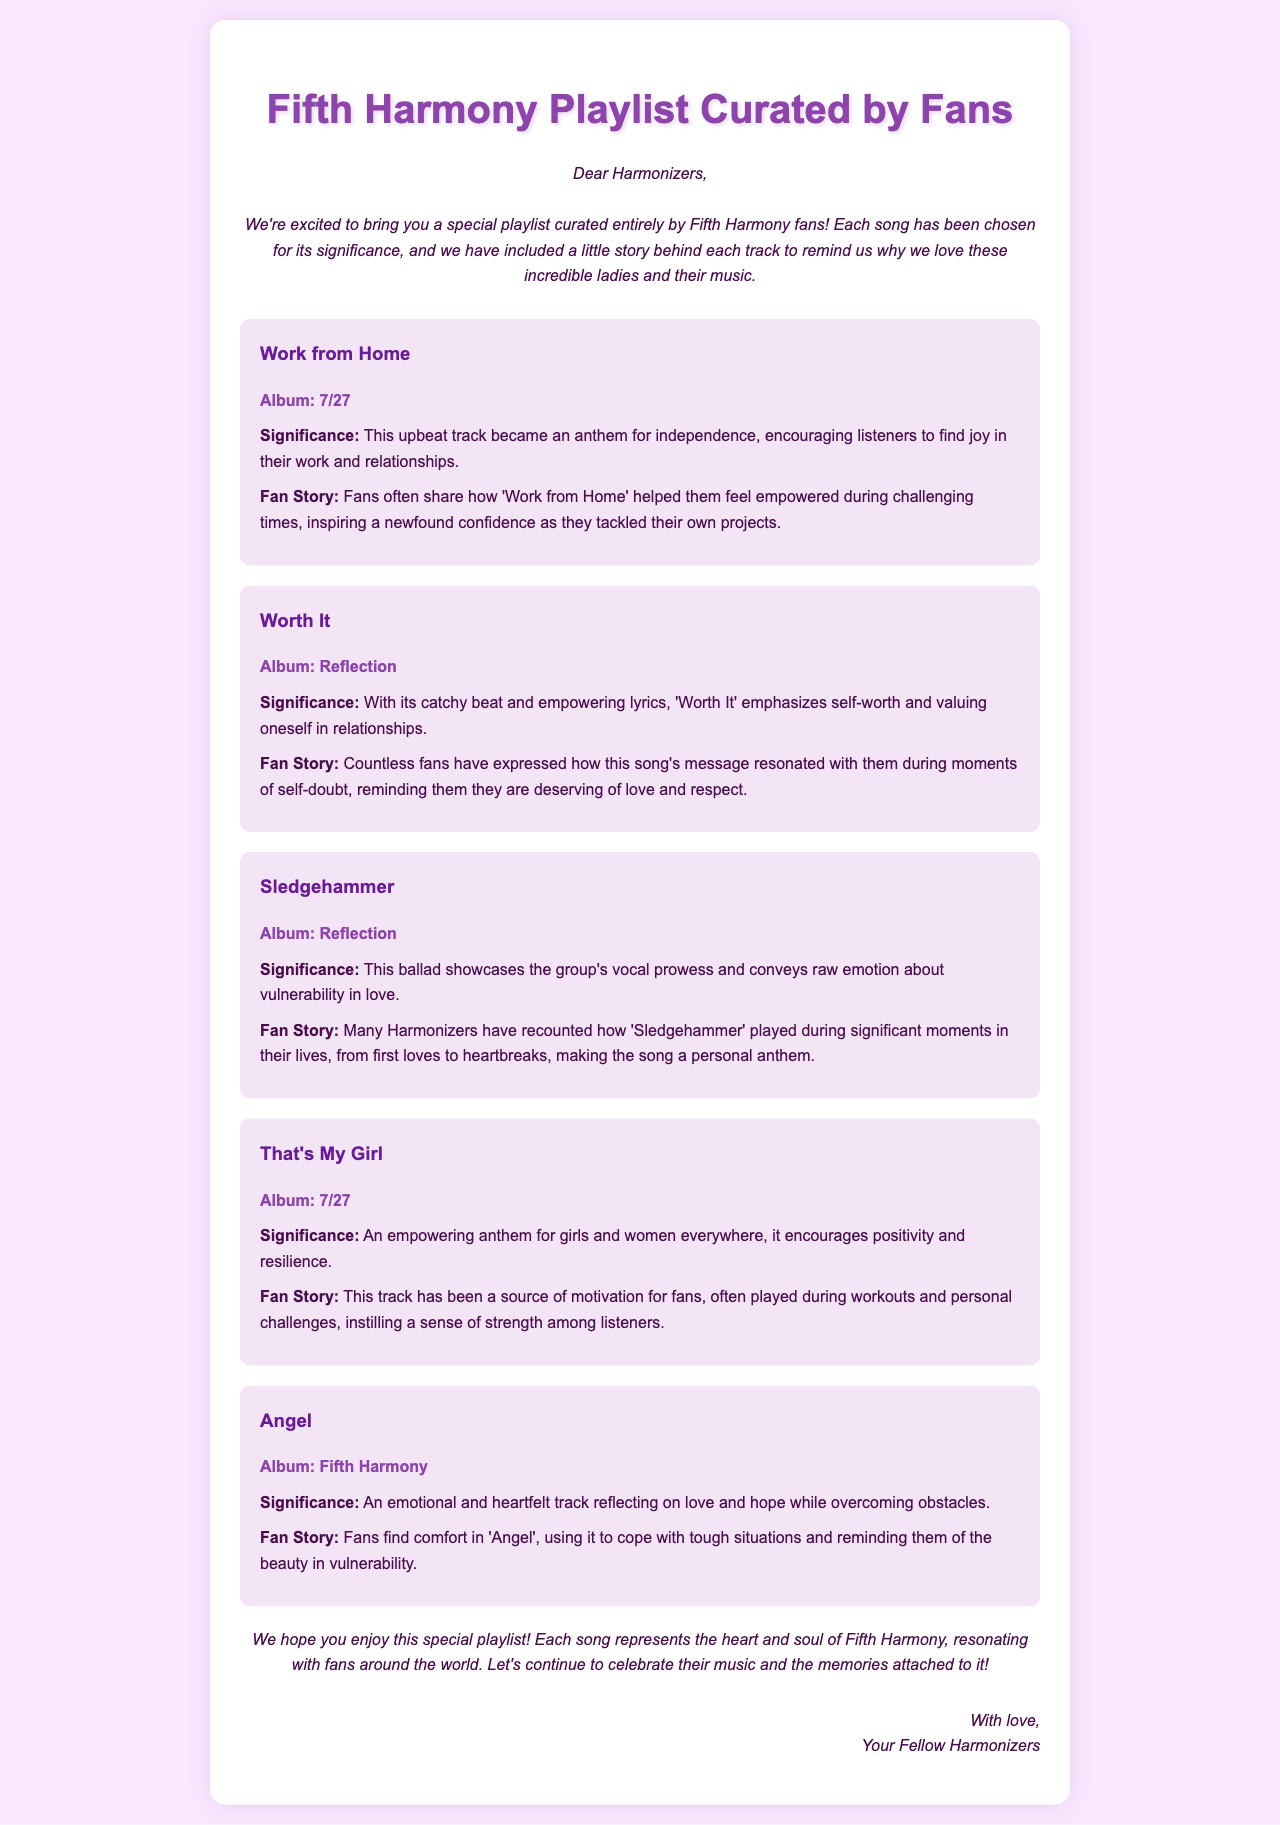What is the title of the playlist? The title of the playlist is presented prominently at the top of the email.
Answer: Fifth Harmony Playlist Curated by Fans How many songs are in the playlist? The document lists five songs in the playlist.
Answer: 5 Which song is from the album "7/27"? The song listed under the album "7/27" are "Work from Home" and "That's My Girl".
Answer: Work from Home, That's My Girl What does "Worth It" emphasize? The significance of "Worth It" is described in the document as emphasizing self-worth.
Answer: Self-worth Which song has a fan story related to coping with tough situations? The document mentions a fan story about finding comfort in a certain song when coping with tough situations.
Answer: Angel What is the opening greeting in the email? The opening greeting introduces the content of the email and addresses fans.
Answer: Dear Harmonizers Which song is described as an empowering anthem for girls? The description specifically highlights a song as an anthem for girls and women everywhere.
Answer: That's My Girl What type of document is this? This document is styled similarly to a newsletter or announcement email aimed at fans.
Answer: Email 